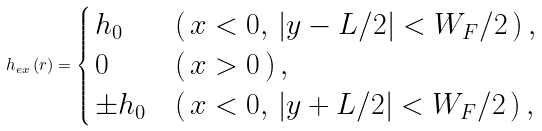Convert formula to latex. <formula><loc_0><loc_0><loc_500><loc_500>h _ { e x } \left ( { r } \right ) = \begin{cases} \, h _ { 0 } & \left ( { \, x < 0 , \, | y - L / 2 | < W _ { F } / 2 \, } \right ) , \\ \, 0 & \left ( { \, x > 0 \, } \right ) , \\ \, \pm h _ { 0 } & \left ( { \, x < 0 , \, | y + L / 2 | < W _ { F } / 2 \, } \right ) , \end{cases}</formula> 